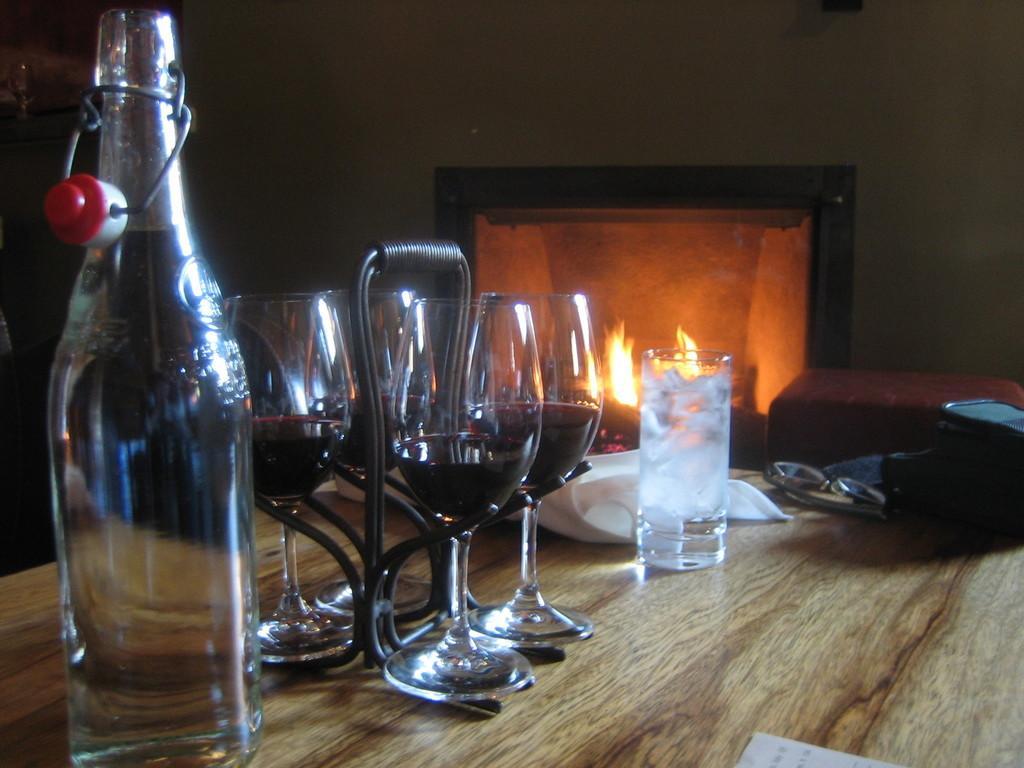Please provide a concise description of this image. In the image there is a table. On table we can see few glasses and a bottle,glass,bag. In background there is a table,fire and a wall. 